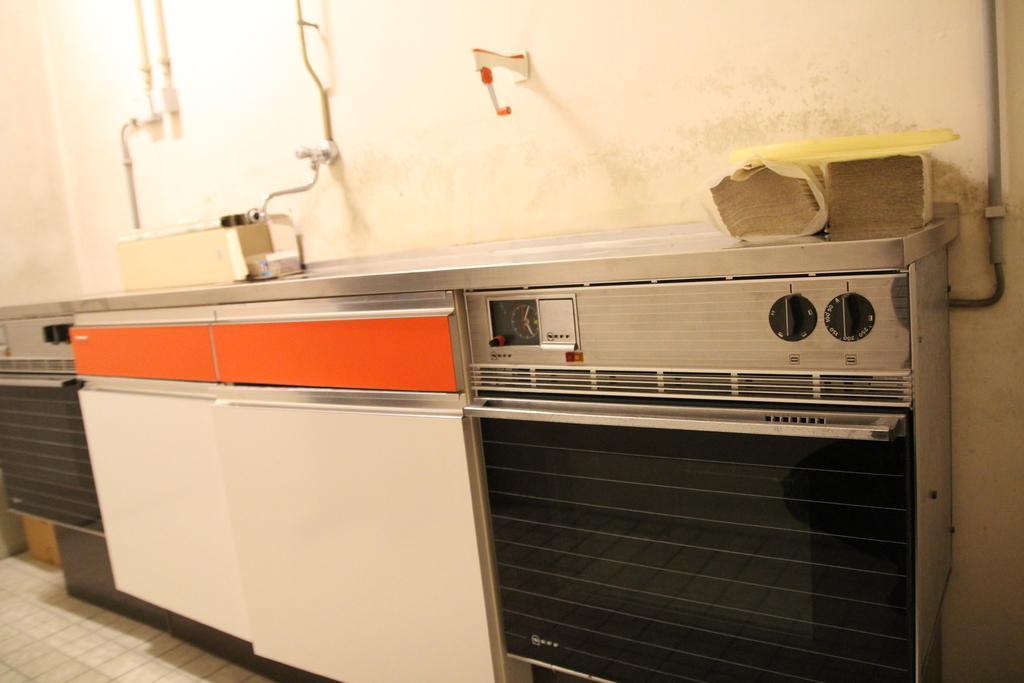Describe this image in one or two sentences. This is inside view. Here I can see the cabinets and a machine on the floor. On this I can see a box and few papers are placed. At the top I can see few metal rods are attached to the wall. 